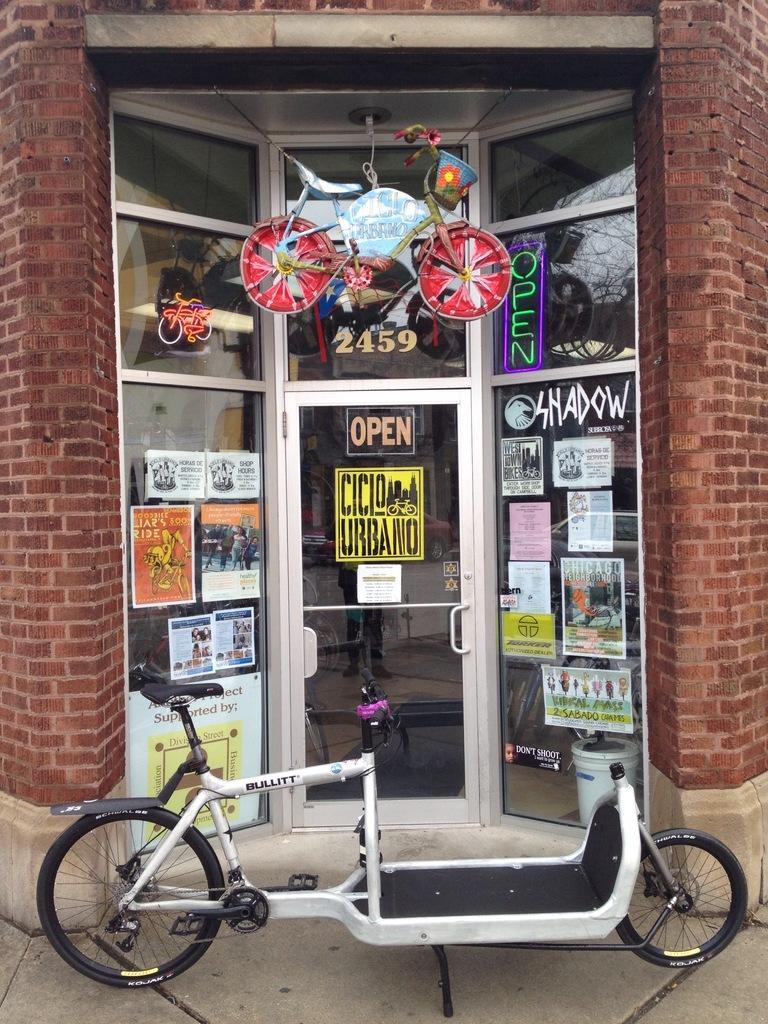Describe this image in one or two sentences. In this image I can see few cycles, a glass door and number of posters. On these posters I can see something is written. 